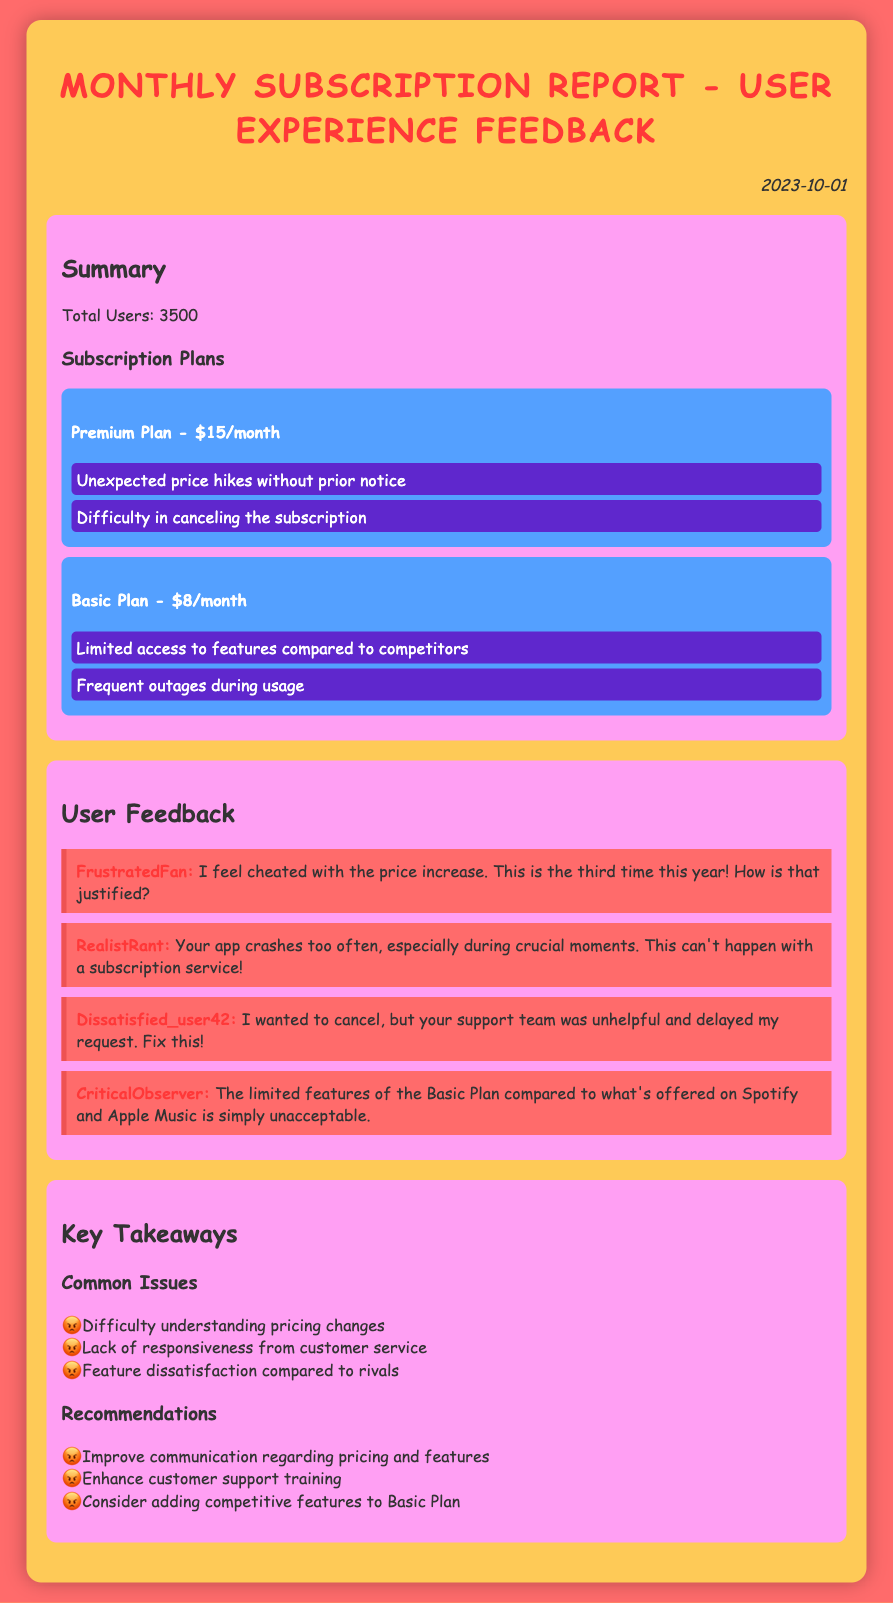what is the date of the report? The report was created on October 1, 2023, as indicated in the date section.
Answer: October 1, 2023 how many total users are reported? The report shows a total of 3500 users in the summary section.
Answer: 3500 what is the price of the Premium Plan? The Premium Plan is listed at $15 per month in the subscription plans section.
Answer: $15/month what are users frustrated with in the Premium Plan? The frustrations listed for the Premium Plan include unexpected price hikes and difficulty in canceling.
Answer: Unexpected price hikes, Difficulty in canceling who commented about the frequent app crashes? The comment regarding frequent app crashes was made by "RealistRant" in the user feedback section.
Answer: RealistRant what features are users dissatisfied with in the Basic Plan? Users are dissatisfied with limited access to features and frequent outages during usage as stated in the feedback.
Answer: Limited access, Frequent outages what recommendations are made for improving customer service? The recommendations include enhancing customer support training as outlined in the recommendations section.
Answer: Enhance customer support training which competitor is mentioned in relation to the Basic Plan's features? The competitors mentioned in comparison to the Basic Plan are Spotify and Apple Music.
Answer: Spotify and Apple Music what common issue relates to pricing changes? The common issue mentioned is the difficulty understanding pricing changes from the report.
Answer: Difficulty understanding pricing changes 